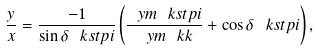Convert formula to latex. <formula><loc_0><loc_0><loc_500><loc_500>\frac { y } { x } = \frac { - 1 } { \sin \delta _ { \ } k s t p i } \left ( \frac { \ y m { \ k s t p i } } { \ y m { \ k k } } + \cos \delta _ { \ } k s t p i \right ) ,</formula> 